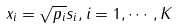Convert formula to latex. <formula><loc_0><loc_0><loc_500><loc_500>x _ { i } = \sqrt { p _ { i } } s _ { i } , i = 1 , \cdots , K</formula> 